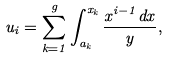Convert formula to latex. <formula><loc_0><loc_0><loc_500><loc_500>u _ { i } = \sum _ { k = 1 } ^ { g } \int _ { a _ { k } } ^ { x _ { k } } \frac { x ^ { i - 1 } d x } { y } ,</formula> 